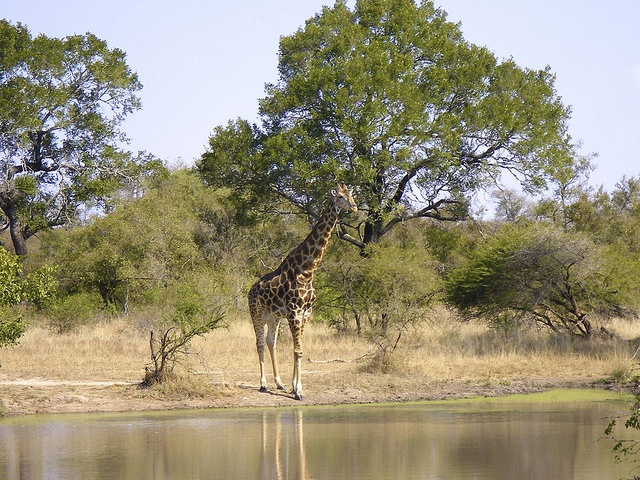Describe the objects in this image and their specific colors. I can see a giraffe in lavender, black, gray, and tan tones in this image. 